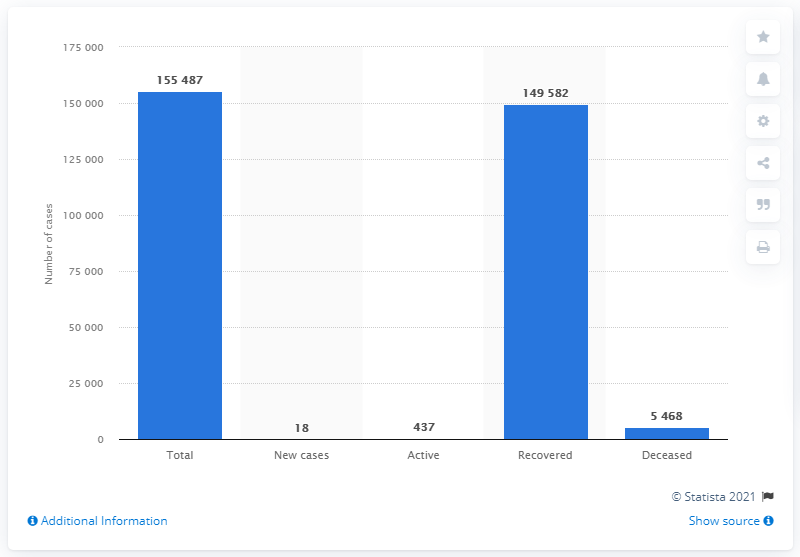Give some essential details in this illustration. On June 10, 2021, a total of 18 new cases of coronavirus were announced in North Macedonia. As of today, 437 individuals remain infected with COVID-19. 